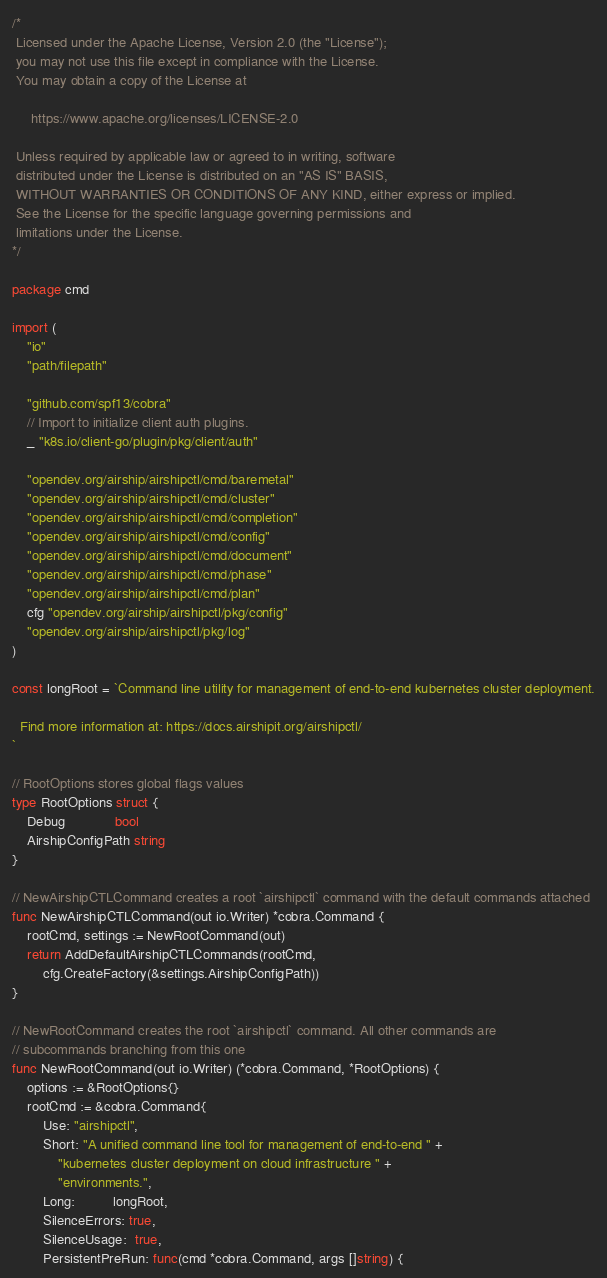Convert code to text. <code><loc_0><loc_0><loc_500><loc_500><_Go_>/*
 Licensed under the Apache License, Version 2.0 (the "License");
 you may not use this file except in compliance with the License.
 You may obtain a copy of the License at

     https://www.apache.org/licenses/LICENSE-2.0

 Unless required by applicable law or agreed to in writing, software
 distributed under the License is distributed on an "AS IS" BASIS,
 WITHOUT WARRANTIES OR CONDITIONS OF ANY KIND, either express or implied.
 See the License for the specific language governing permissions and
 limitations under the License.
*/

package cmd

import (
	"io"
	"path/filepath"

	"github.com/spf13/cobra"
	// Import to initialize client auth plugins.
	_ "k8s.io/client-go/plugin/pkg/client/auth"

	"opendev.org/airship/airshipctl/cmd/baremetal"
	"opendev.org/airship/airshipctl/cmd/cluster"
	"opendev.org/airship/airshipctl/cmd/completion"
	"opendev.org/airship/airshipctl/cmd/config"
	"opendev.org/airship/airshipctl/cmd/document"
	"opendev.org/airship/airshipctl/cmd/phase"
	"opendev.org/airship/airshipctl/cmd/plan"
	cfg "opendev.org/airship/airshipctl/pkg/config"
	"opendev.org/airship/airshipctl/pkg/log"
)

const longRoot = `Command line utility for management of end-to-end kubernetes cluster deployment.

  Find more information at: https://docs.airshipit.org/airshipctl/
`

// RootOptions stores global flags values
type RootOptions struct {
	Debug             bool
	AirshipConfigPath string
}

// NewAirshipCTLCommand creates a root `airshipctl` command with the default commands attached
func NewAirshipCTLCommand(out io.Writer) *cobra.Command {
	rootCmd, settings := NewRootCommand(out)
	return AddDefaultAirshipCTLCommands(rootCmd,
		cfg.CreateFactory(&settings.AirshipConfigPath))
}

// NewRootCommand creates the root `airshipctl` command. All other commands are
// subcommands branching from this one
func NewRootCommand(out io.Writer) (*cobra.Command, *RootOptions) {
	options := &RootOptions{}
	rootCmd := &cobra.Command{
		Use: "airshipctl",
		Short: "A unified command line tool for management of end-to-end " +
			"kubernetes cluster deployment on cloud infrastructure " +
			"environments.",
		Long:          longRoot,
		SilenceErrors: true,
		SilenceUsage:  true,
		PersistentPreRun: func(cmd *cobra.Command, args []string) {</code> 